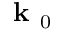<formula> <loc_0><loc_0><loc_500><loc_500>k _ { 0 }</formula> 